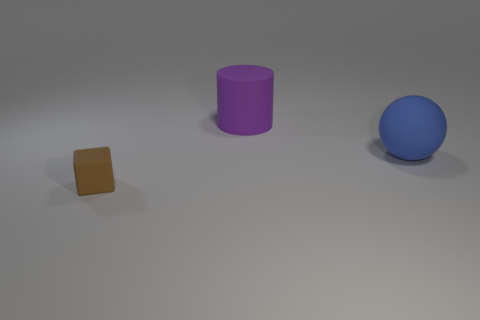Add 1 small gray cylinders. How many objects exist? 4 Subtract 1 purple cylinders. How many objects are left? 2 Subtract all balls. How many objects are left? 2 Subtract all small yellow matte cylinders. Subtract all cylinders. How many objects are left? 2 Add 3 purple things. How many purple things are left? 4 Add 3 big purple things. How many big purple things exist? 4 